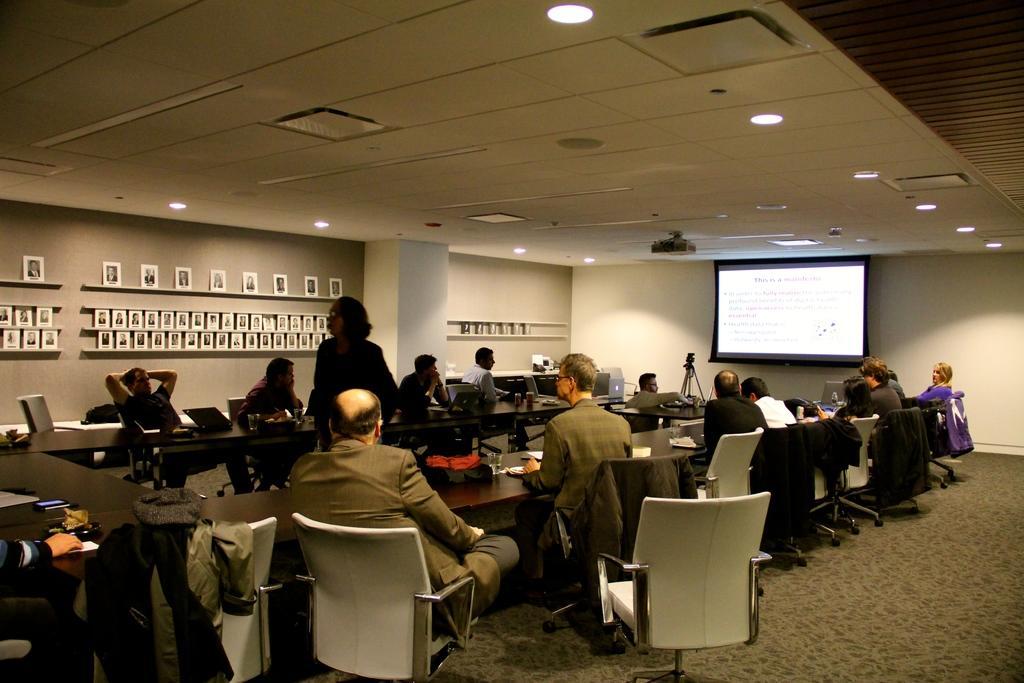Could you give a brief overview of what you see in this image? In this image i can see a group of people sitting in a conference hall and a woman standing in the middle of the hall and in the background i can see a projection screen and to a ceiling i can see few lights and to the left wall i can see some photos hanged into it. 